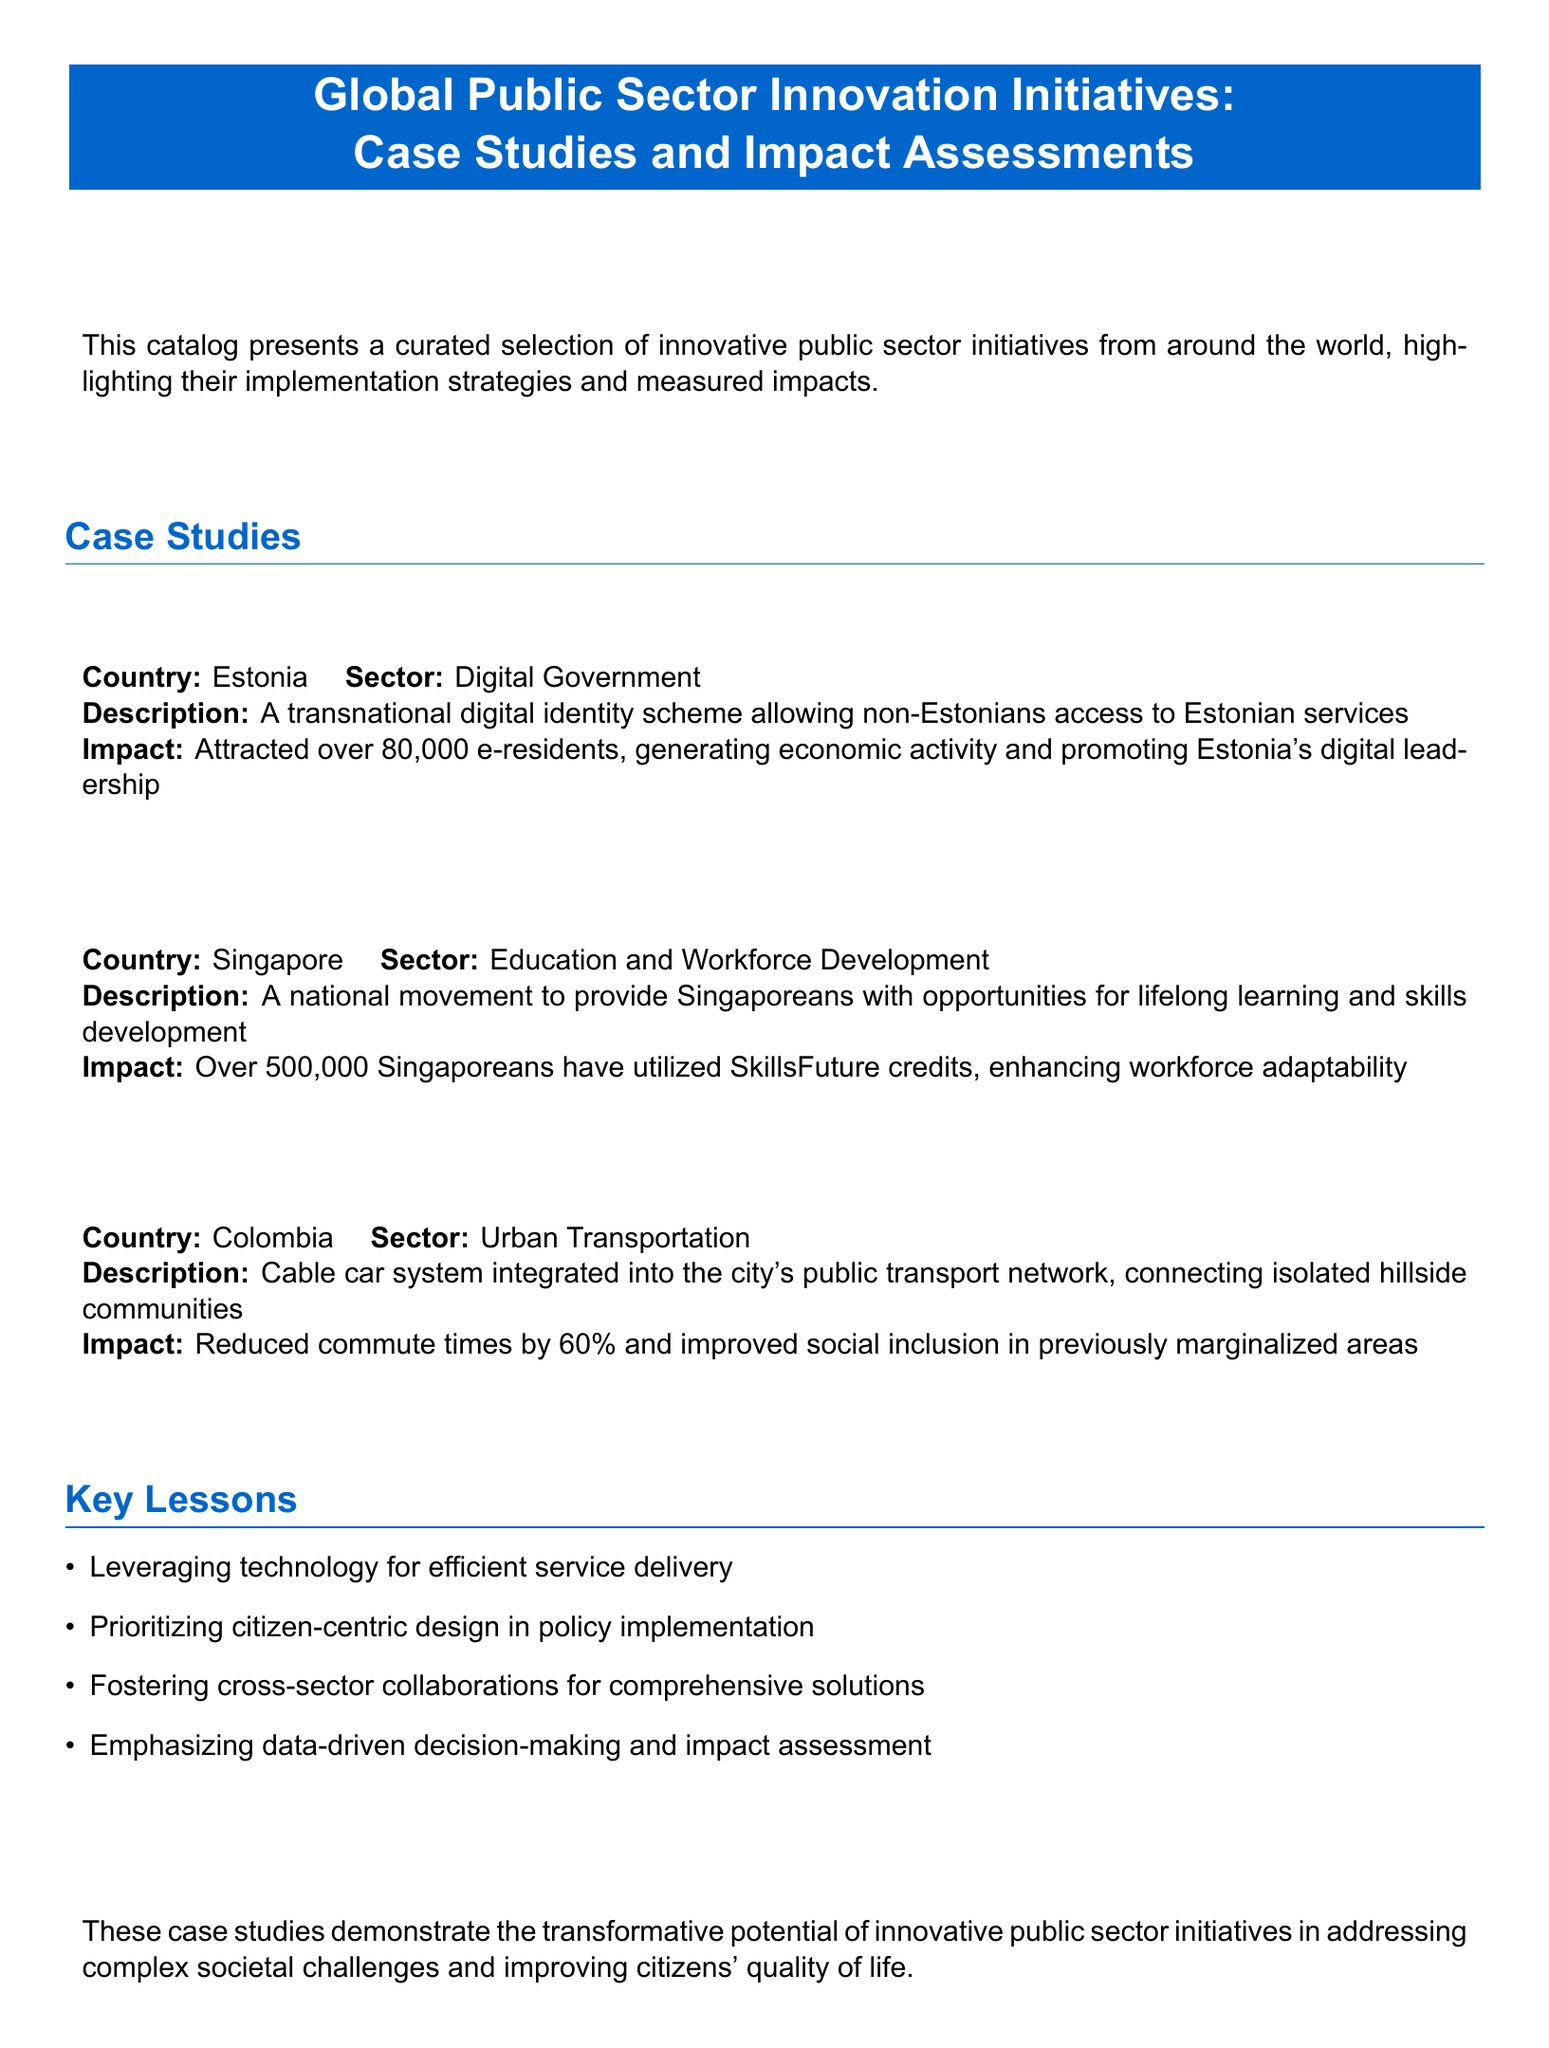what is the title of the catalog? The title of the catalog is listed at the top of the document and highlights the focus on global public sector innovation initiatives.
Answer: Global Public Sector Innovation Initiatives: Case Studies and Impact Assessments which country implemented the e-Residency Program? The e-Residency Program is specifically attributed to a country mentioned in the document.
Answer: Estonia how many e-residents has Estonia's e-Residency Program attracted? The document provides a specific number regarding the attraction of e-residents by this program.
Answer: over 80,000 what is one impact of Singapore's SkillsFuture Initiative? The document lists specific impacts related to the SkillsFuture Initiative, including a quantifiable outcome.
Answer: Over 500,000 Singaporeans have utilized SkillsFuture credits which transport sector innovation is highlighted in Colombia? This question seeks to identify the specific innovation within the transportation sector mentioned in the case studies.
Answer: Medellín Metrocable what percentage did commute times reduce by with the Medellín Metrocable? The document contains a specific percentage related to the impact of the Medellín Metrocable on commute times.
Answer: 60% which key lesson emphasizes data-driven decision-making? The document outlines key lessons from the case studies, one of which mentions data-driven approaches.
Answer: Emphasizing data-driven decision-making and impact assessment what type of design is prioritized in policy implementation according to the key lessons? The document lists a specific design approach that is prioritized and aligns with citizen engagement.
Answer: citizen-centric design what do the case studies demonstrate about innovative public sector initiatives? This question targets the broader implication of case studies shared in the document regarding public sector innovation.
Answer: transformative potential 